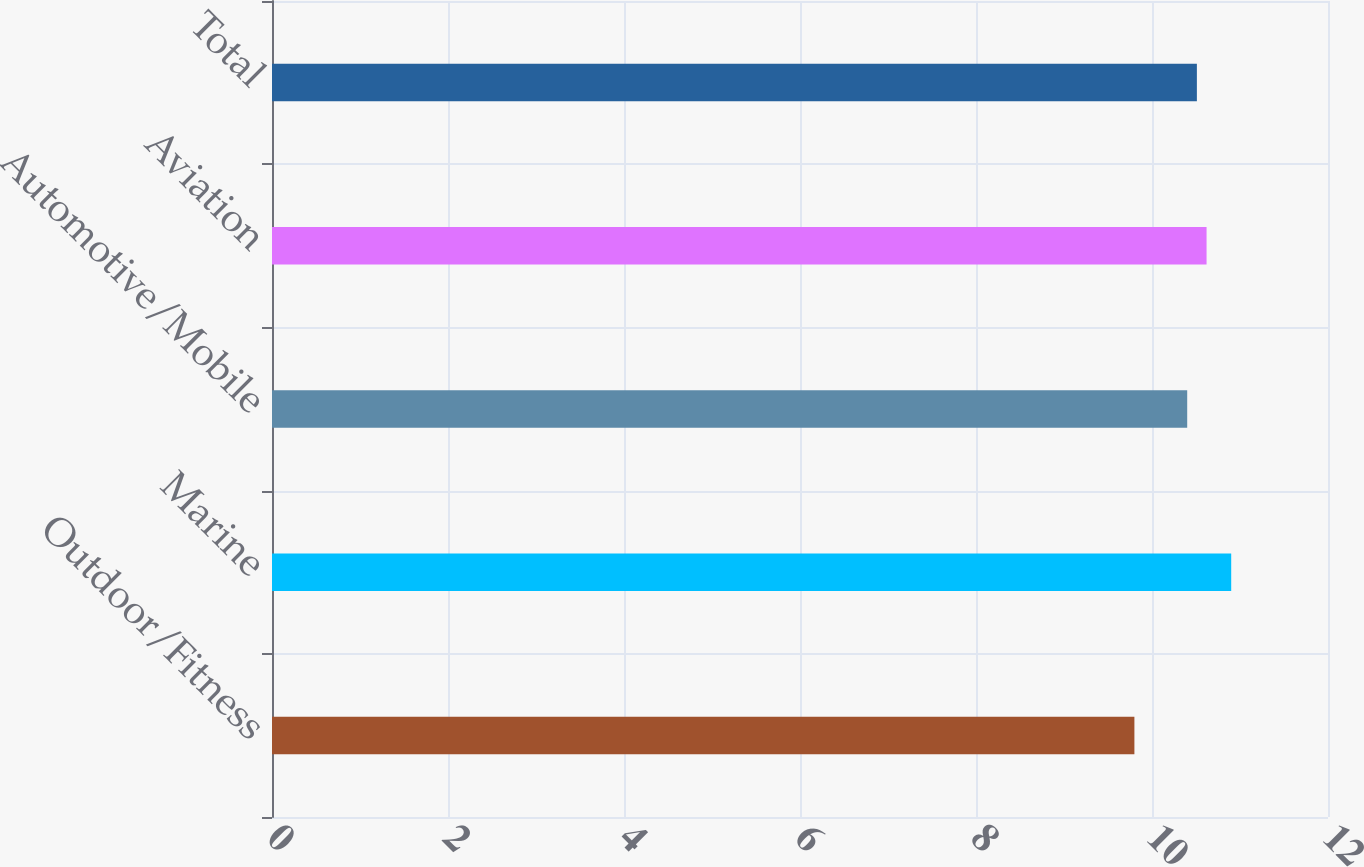Convert chart. <chart><loc_0><loc_0><loc_500><loc_500><bar_chart><fcel>Outdoor/Fitness<fcel>Marine<fcel>Automotive/Mobile<fcel>Aviation<fcel>Total<nl><fcel>9.8<fcel>10.9<fcel>10.4<fcel>10.62<fcel>10.51<nl></chart> 